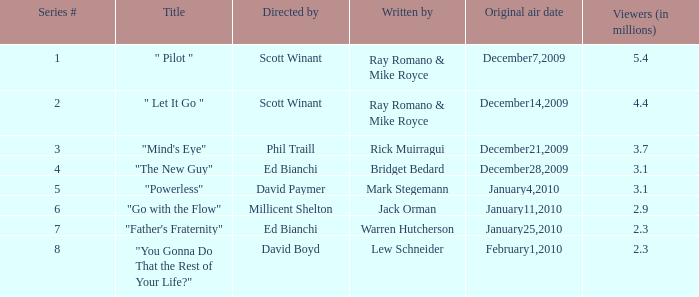Would you mind parsing the complete table? {'header': ['Series #', 'Title', 'Directed by', 'Written by', 'Original air date', 'Viewers (in millions)'], 'rows': [['1', '" Pilot "', 'Scott Winant', 'Ray Romano & Mike Royce', 'December7,2009', '5.4'], ['2', '" Let It Go "', 'Scott Winant', 'Ray Romano & Mike Royce', 'December14,2009', '4.4'], ['3', '"Mind\'s Eye"', 'Phil Traill', 'Rick Muirragui', 'December21,2009', '3.7'], ['4', '"The New Guy"', 'Ed Bianchi', 'Bridget Bedard', 'December28,2009', '3.1'], ['5', '"Powerless"', 'David Paymer', 'Mark Stegemann', 'January4,2010', '3.1'], ['6', '"Go with the Flow"', 'Millicent Shelton', 'Jack Orman', 'January11,2010', '2.9'], ['7', '"Father\'s Fraternity"', 'Ed Bianchi', 'Warren Hutcherson', 'January25,2010', '2.3'], ['8', '"You Gonna Do That the Rest of Your Life?"', 'David Boyd', 'Lew Schneider', 'February1,2010', '2.3']]} How many episodes are written by Lew Schneider? 1.0. 